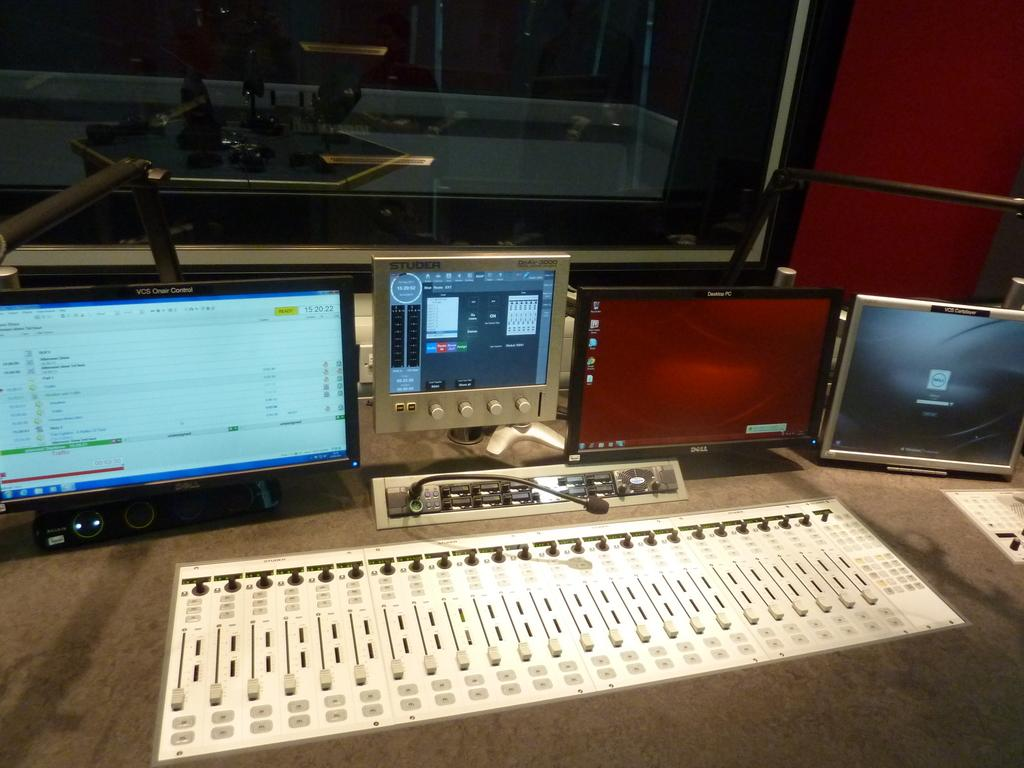<image>
Render a clear and concise summary of the photo. A computer screen among other things which has the word Dell on it 